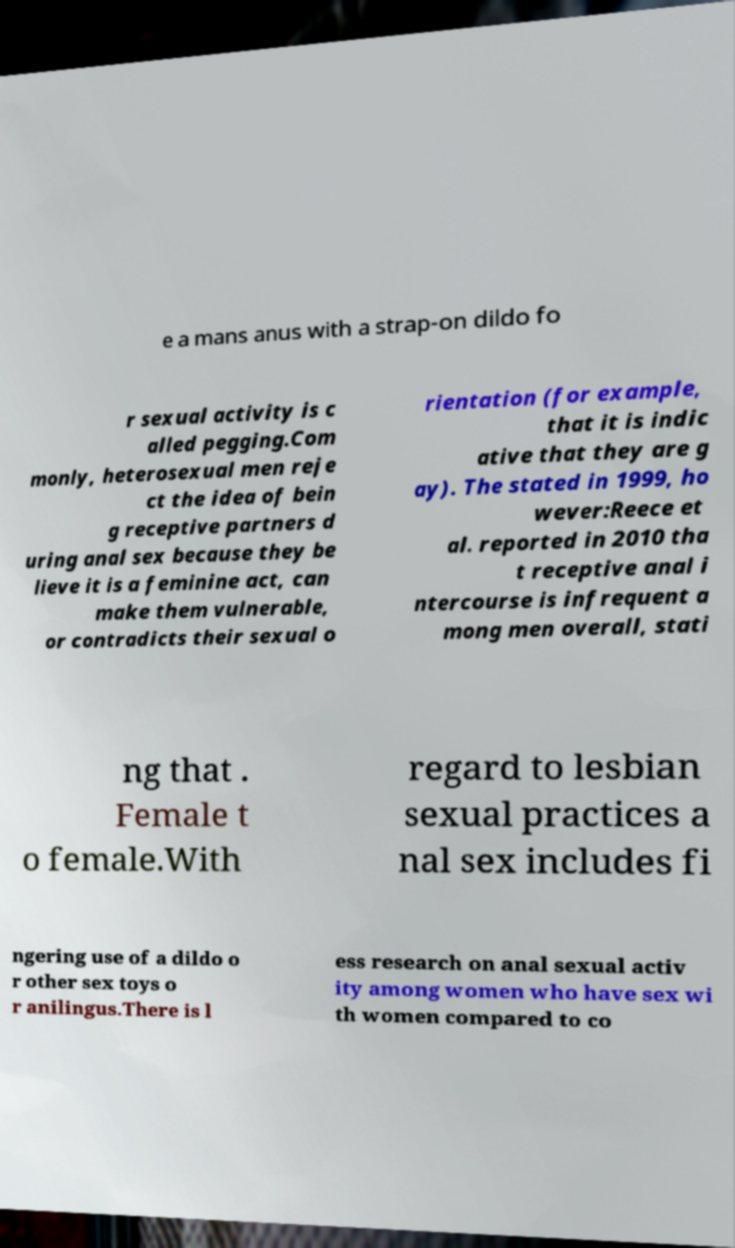What messages or text are displayed in this image? I need them in a readable, typed format. e a mans anus with a strap-on dildo fo r sexual activity is c alled pegging.Com monly, heterosexual men reje ct the idea of bein g receptive partners d uring anal sex because they be lieve it is a feminine act, can make them vulnerable, or contradicts their sexual o rientation (for example, that it is indic ative that they are g ay). The stated in 1999, ho wever:Reece et al. reported in 2010 tha t receptive anal i ntercourse is infrequent a mong men overall, stati ng that . Female t o female.With regard to lesbian sexual practices a nal sex includes fi ngering use of a dildo o r other sex toys o r anilingus.There is l ess research on anal sexual activ ity among women who have sex wi th women compared to co 